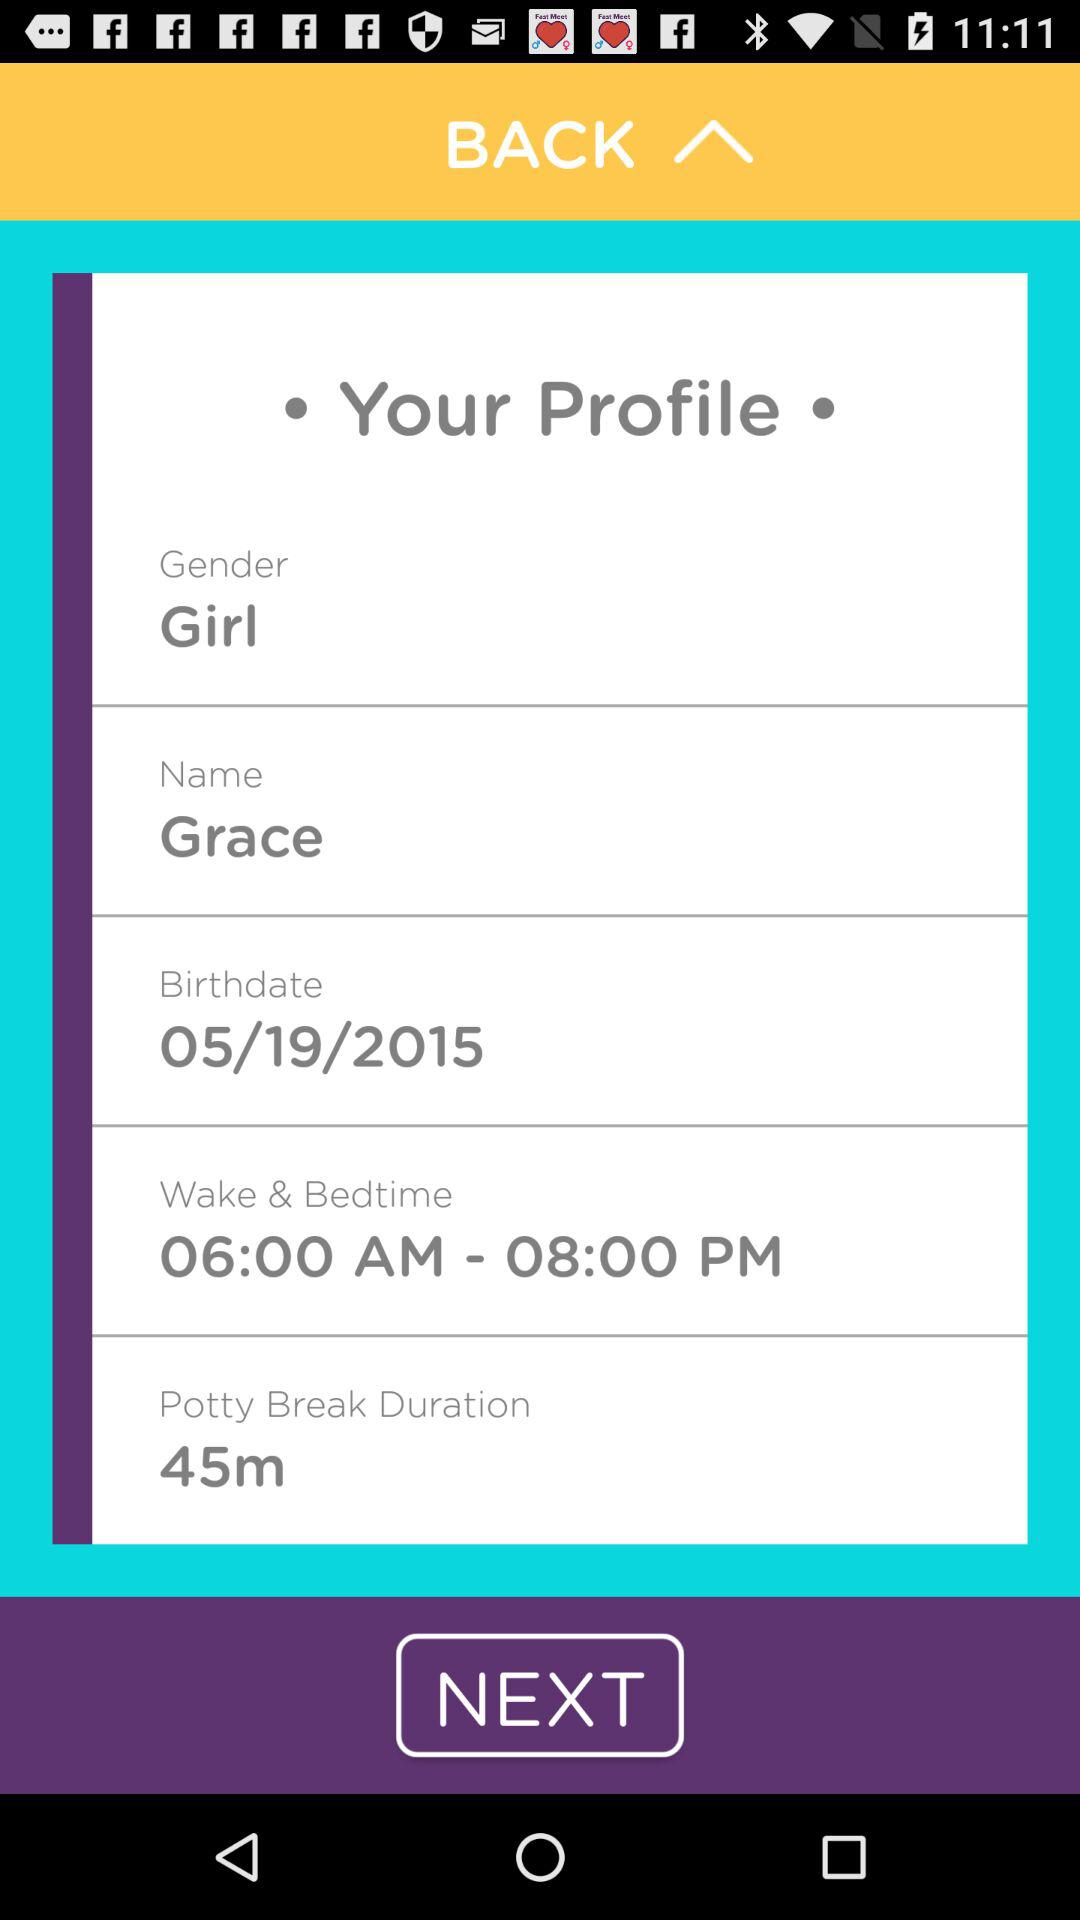What is the gender? It is a girl. 